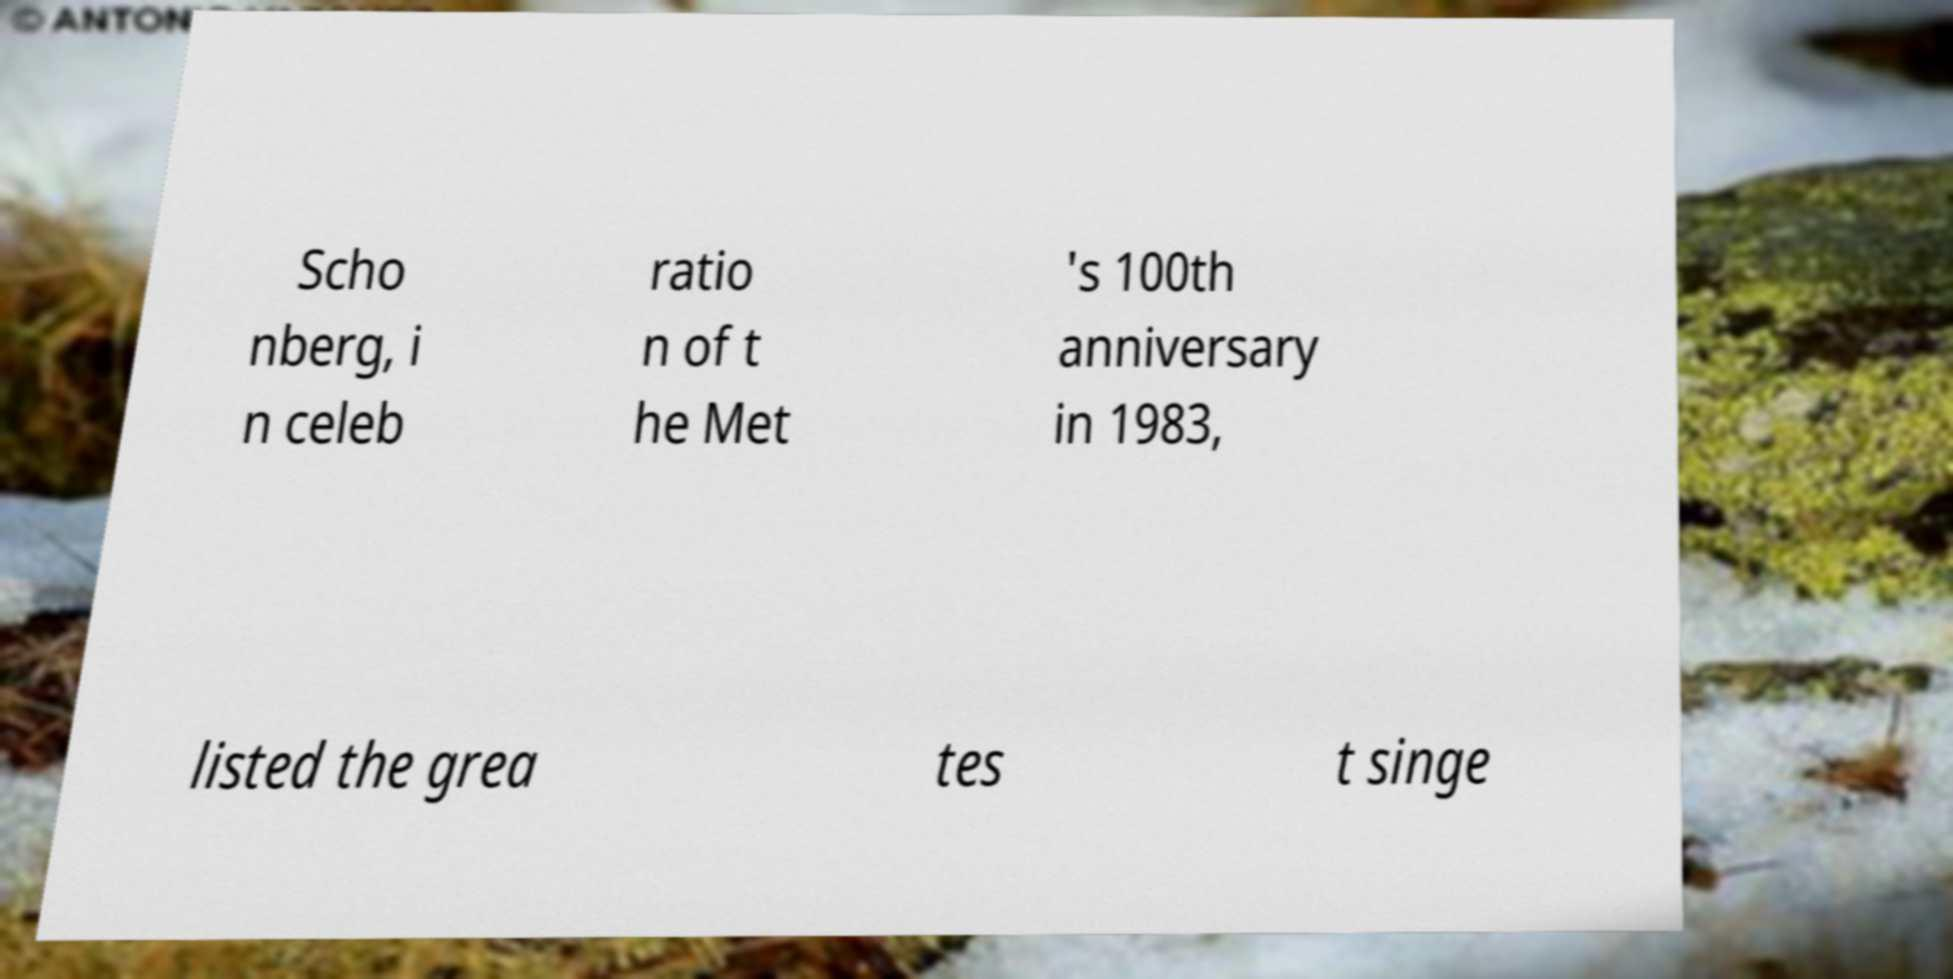I need the written content from this picture converted into text. Can you do that? Scho nberg, i n celeb ratio n of t he Met 's 100th anniversary in 1983, listed the grea tes t singe 